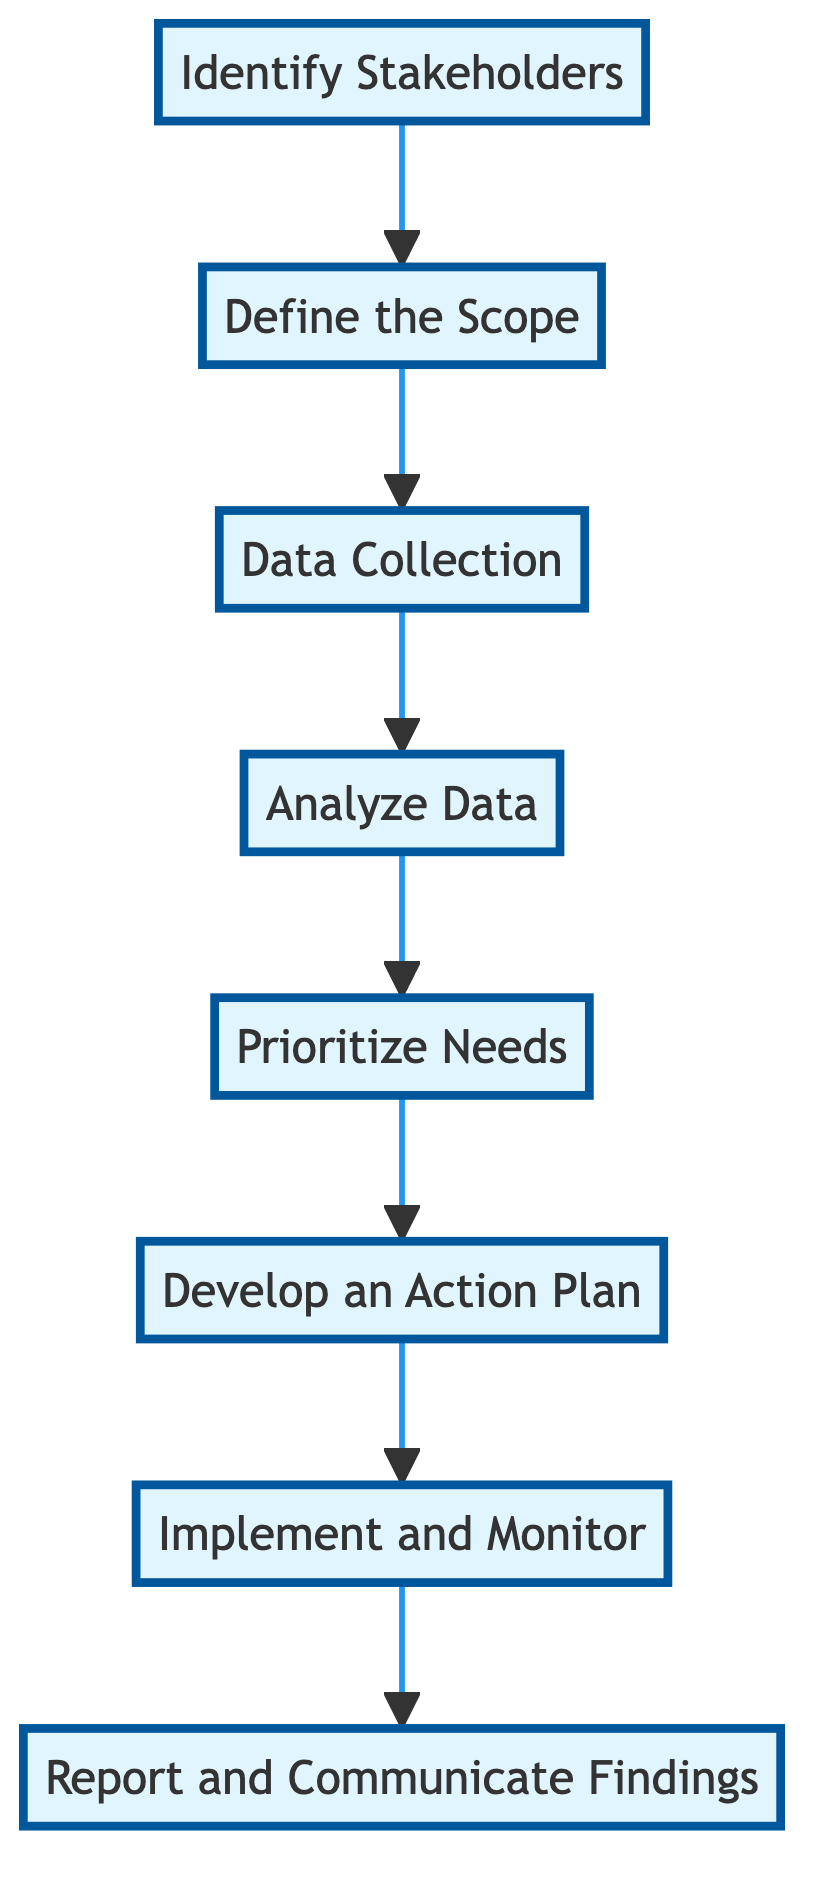What is the first step in the assessment process? The diagram shows that the first step is "Identify Stakeholders", which is the initial action in the flowchart.
Answer: Identify Stakeholders How many total steps are in the diagram? By reviewing the nodes in the flowchart, we see there are 8 steps listed, ranging from identifying stakeholders to reporting findings.
Answer: 8 What is the last step listed in the flowchart? The diagram indicates that "Report and Communicate Findings" is the final step, positioned at the end of the flowchart sequence.
Answer: Report and Communicate Findings Which step follows "Data Collection"? The flowchart shows an arrow from "Data Collection" leading directly to "Analyze Data", indicating that data analysis occurs next in sequence.
Answer: Analyze Data What is the primary focus of the "Define the Scope" step? In the diagram, the "Define the Scope" step focuses on determining the geographical and demographic areas relevant to the health needs assessment, as detailed in the description.
Answer: Determine geographical and demographic scope What is the process after prioritizing needs? Following the "Prioritize Needs" step, the flowchart leads to "Develop an Action Plan", which outlines the next phase in the health needs assessment process.
Answer: Develop an Action Plan What should be included in the action plan? The description of "Develop an Action Plan" emphasizes outlining strategies, responsible parties, timelines, and required resources, which are crucial components of the action plan.
Answer: Strategies, responsible parties, timelines, and required resources How does the diagram communicate the flow between steps? The arrows connecting each step in the flowchart illustrate the directional flow of the process, indicating how one step leads to the next in a sequential manner.
Answer: Arrows connecting steps 